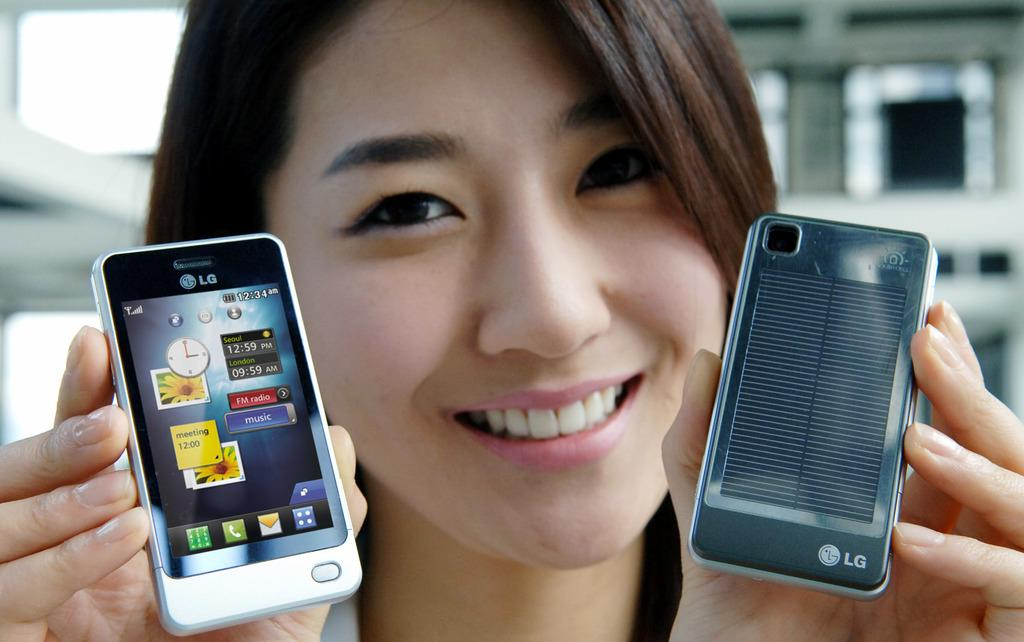<image>
Write a terse but informative summary of the picture. A smiling young woman showing the front and back of a LG cell phone. 